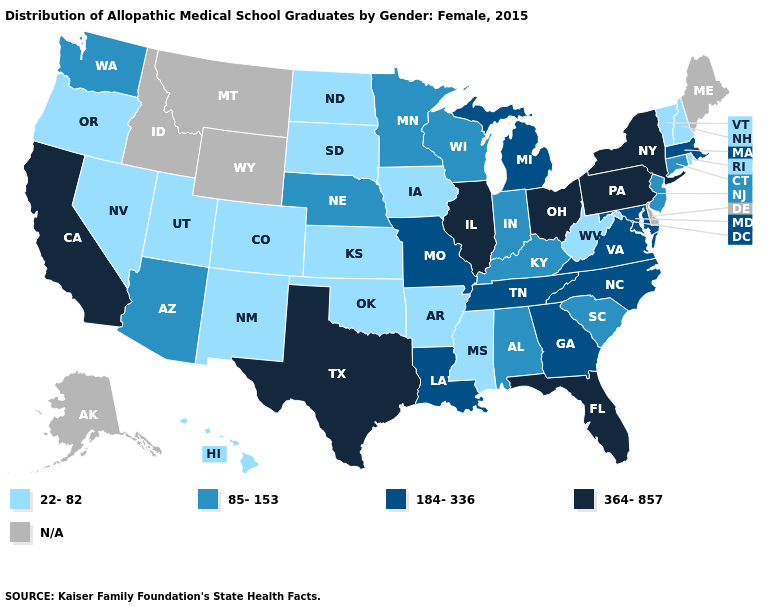Does New York have the highest value in the USA?
Quick response, please. Yes. What is the lowest value in the West?
Quick response, please. 22-82. What is the highest value in the USA?
Keep it brief. 364-857. Is the legend a continuous bar?
Give a very brief answer. No. Does the map have missing data?
Be succinct. Yes. What is the value of Kentucky?
Write a very short answer. 85-153. Is the legend a continuous bar?
Be succinct. No. What is the highest value in the USA?
Short answer required. 364-857. Among the states that border Ohio , does West Virginia have the highest value?
Short answer required. No. Does South Dakota have the lowest value in the USA?
Be succinct. Yes. 